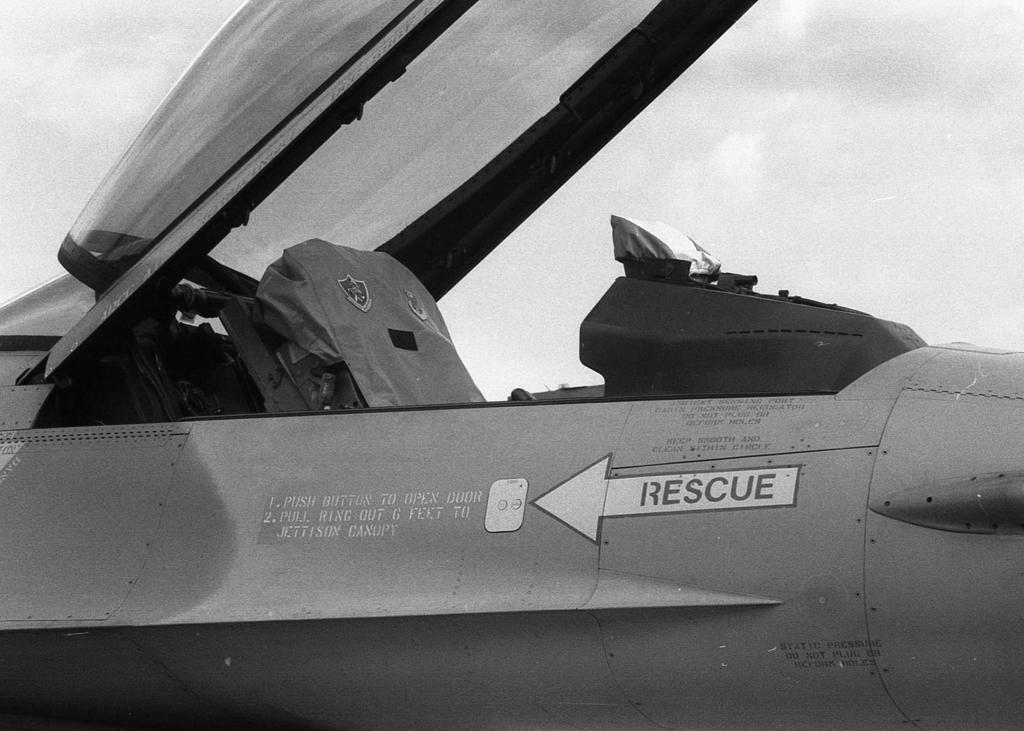How would you summarize this image in a sentence or two? This is a black and white image. In the center of the image there is a aircraft. 